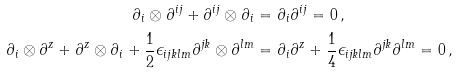<formula> <loc_0><loc_0><loc_500><loc_500>\partial _ { i } \otimes \partial ^ { i j } + \partial ^ { i j } \otimes \partial _ { i } & = \partial _ { i } \partial ^ { i j } = 0 \, , \\ \partial _ { i } \otimes \partial ^ { z } + \partial ^ { z } \otimes \partial _ { i } + \frac { 1 } { 2 } \epsilon _ { i j k l m } \partial ^ { j k } \otimes \partial ^ { l m } & = \partial _ { i } \partial ^ { z } + \frac { 1 } { 4 } \epsilon _ { i j k l m } \partial ^ { j k } \partial ^ { l m } = 0 \, ,</formula> 